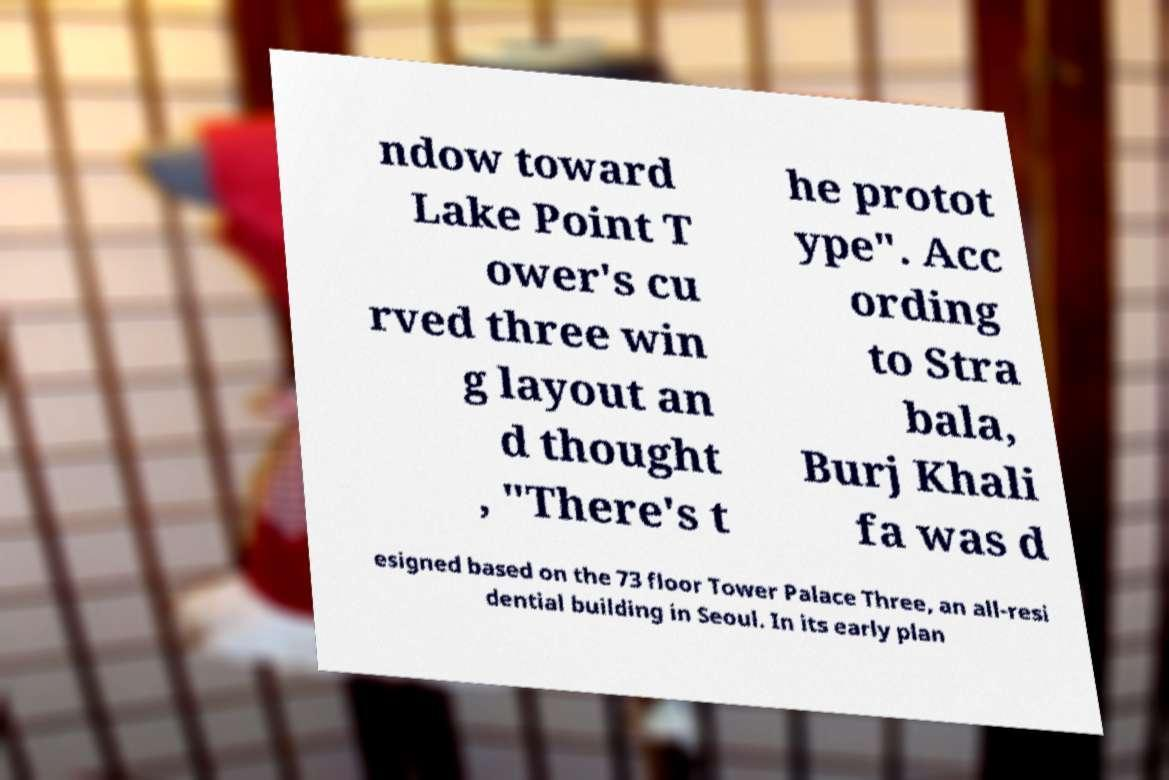Please identify and transcribe the text found in this image. ndow toward Lake Point T ower's cu rved three win g layout an d thought , "There's t he protot ype". Acc ording to Stra bala, Burj Khali fa was d esigned based on the 73 floor Tower Palace Three, an all-resi dential building in Seoul. In its early plan 